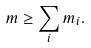<formula> <loc_0><loc_0><loc_500><loc_500>m \geq \sum _ { i } m _ { i } .</formula> 